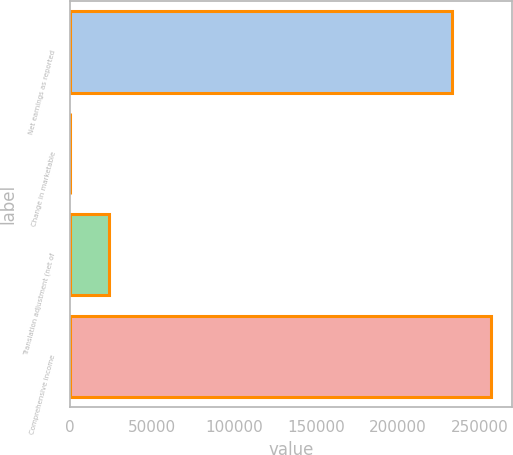<chart> <loc_0><loc_0><loc_500><loc_500><bar_chart><fcel>Net earnings as reported<fcel>Change in marketable<fcel>Translation adjustment (net of<fcel>Comprehensive income<nl><fcel>232622<fcel>102<fcel>24059.9<fcel>256580<nl></chart> 